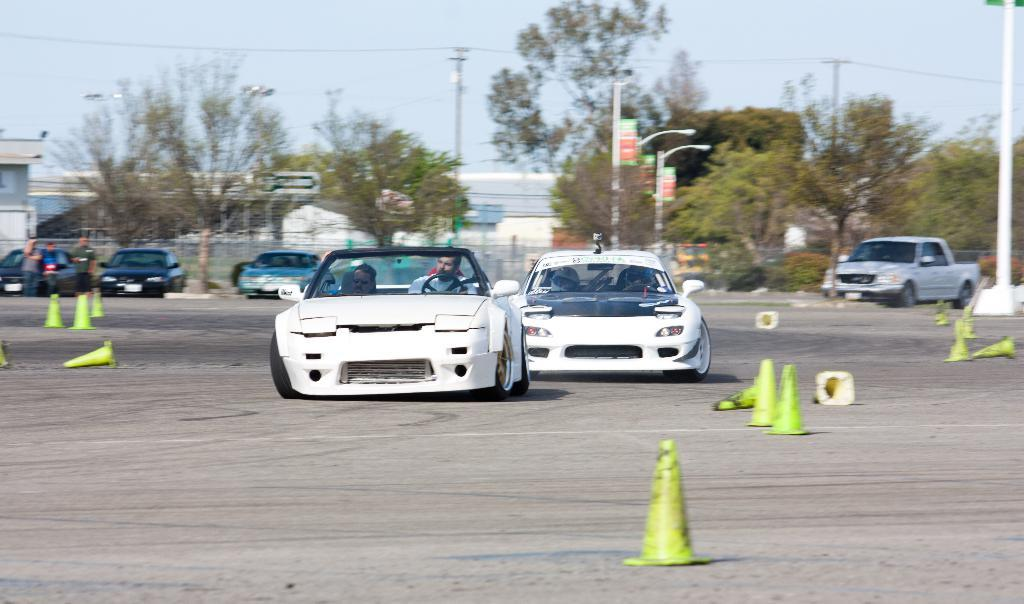What can be seen in the foreground of the image? In the foreground of the image, there are cars and traffic cones. What is visible in the background of the image? In the background of the image, there are people, vehicles, poles, trees, wires, and the sky. How many types of objects can be seen in the background? There are at least seven types of objects visible in the background: people, vehicles, poles, trees, wires, and the sky. Where can the hand holding a calculator be found in the image? There is no hand holding a calculator present in the image. What type of plants are visible in the image? There are no plants visible in the image; only trees are mentioned in the background. 